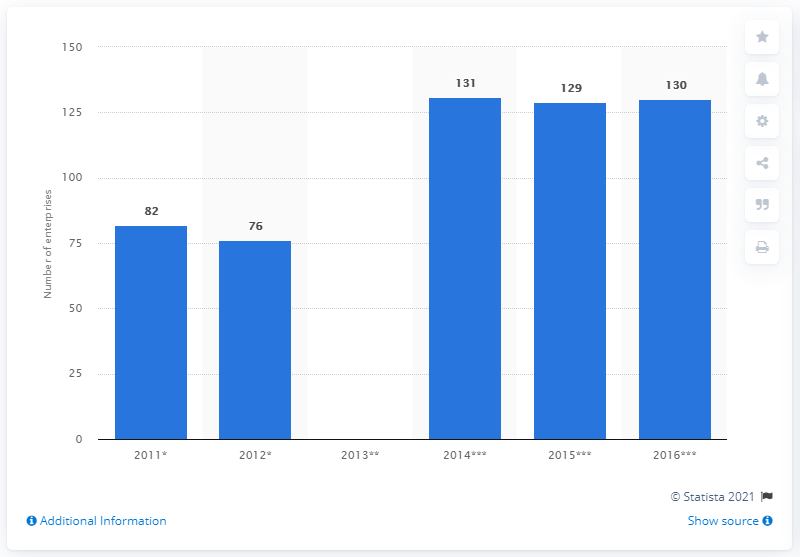Identify some key points in this picture. In 2016, 130 enterprises in Bosnia and Herzegovina manufactured footwear. 